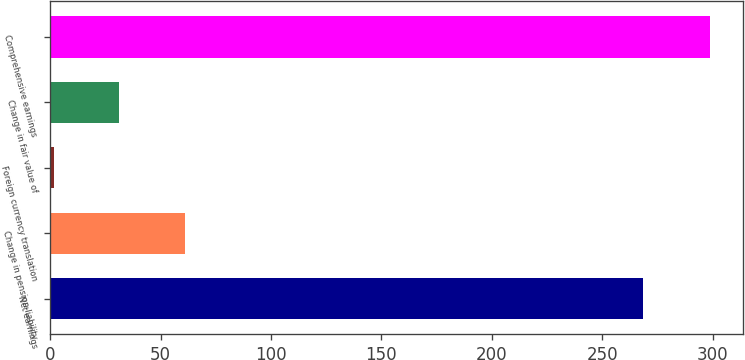Convert chart. <chart><loc_0><loc_0><loc_500><loc_500><bar_chart><fcel>Net earnings<fcel>Change in pension liability<fcel>Foreign currency translation<fcel>Change in fair value of<fcel>Comprehensive earnings<nl><fcel>268.6<fcel>61.04<fcel>1.6<fcel>31.32<fcel>298.8<nl></chart> 